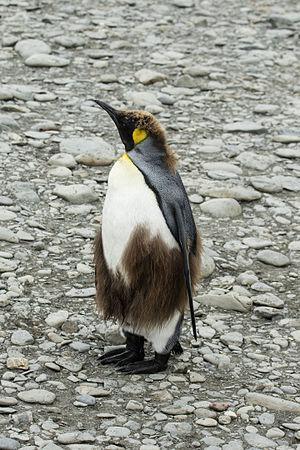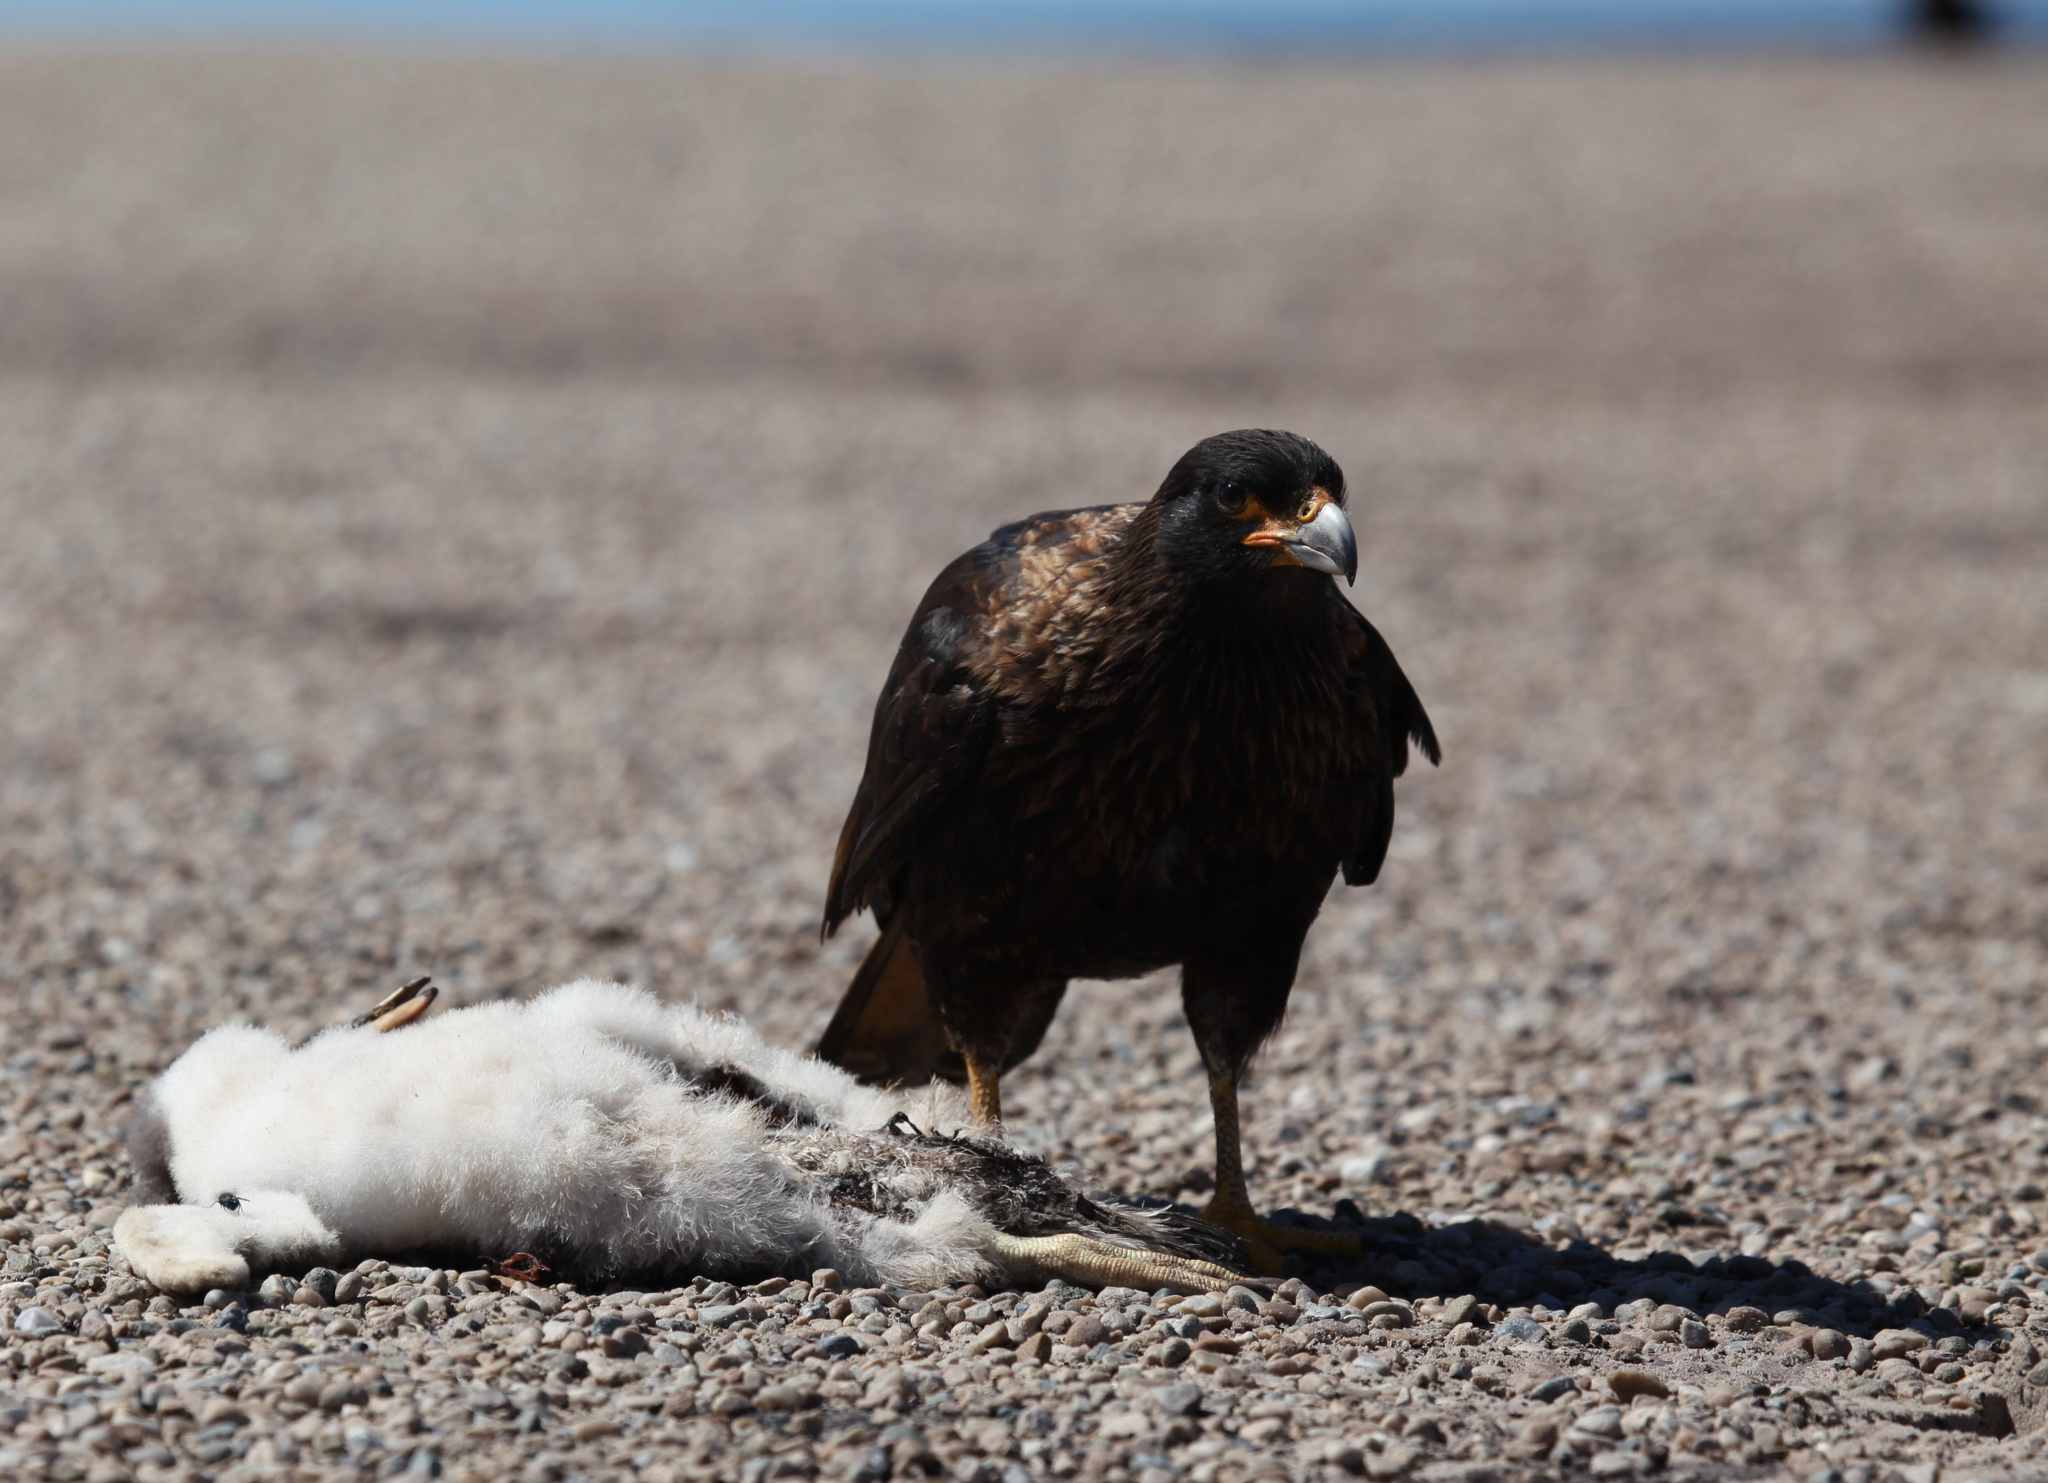The first image is the image on the left, the second image is the image on the right. Given the left and right images, does the statement "There are three or fewer penguins in total." hold true? Answer yes or no. Yes. The first image is the image on the left, the second image is the image on the right. For the images shown, is this caption "One of the images shows a single penguin standing on two legs and facing the left." true? Answer yes or no. Yes. 